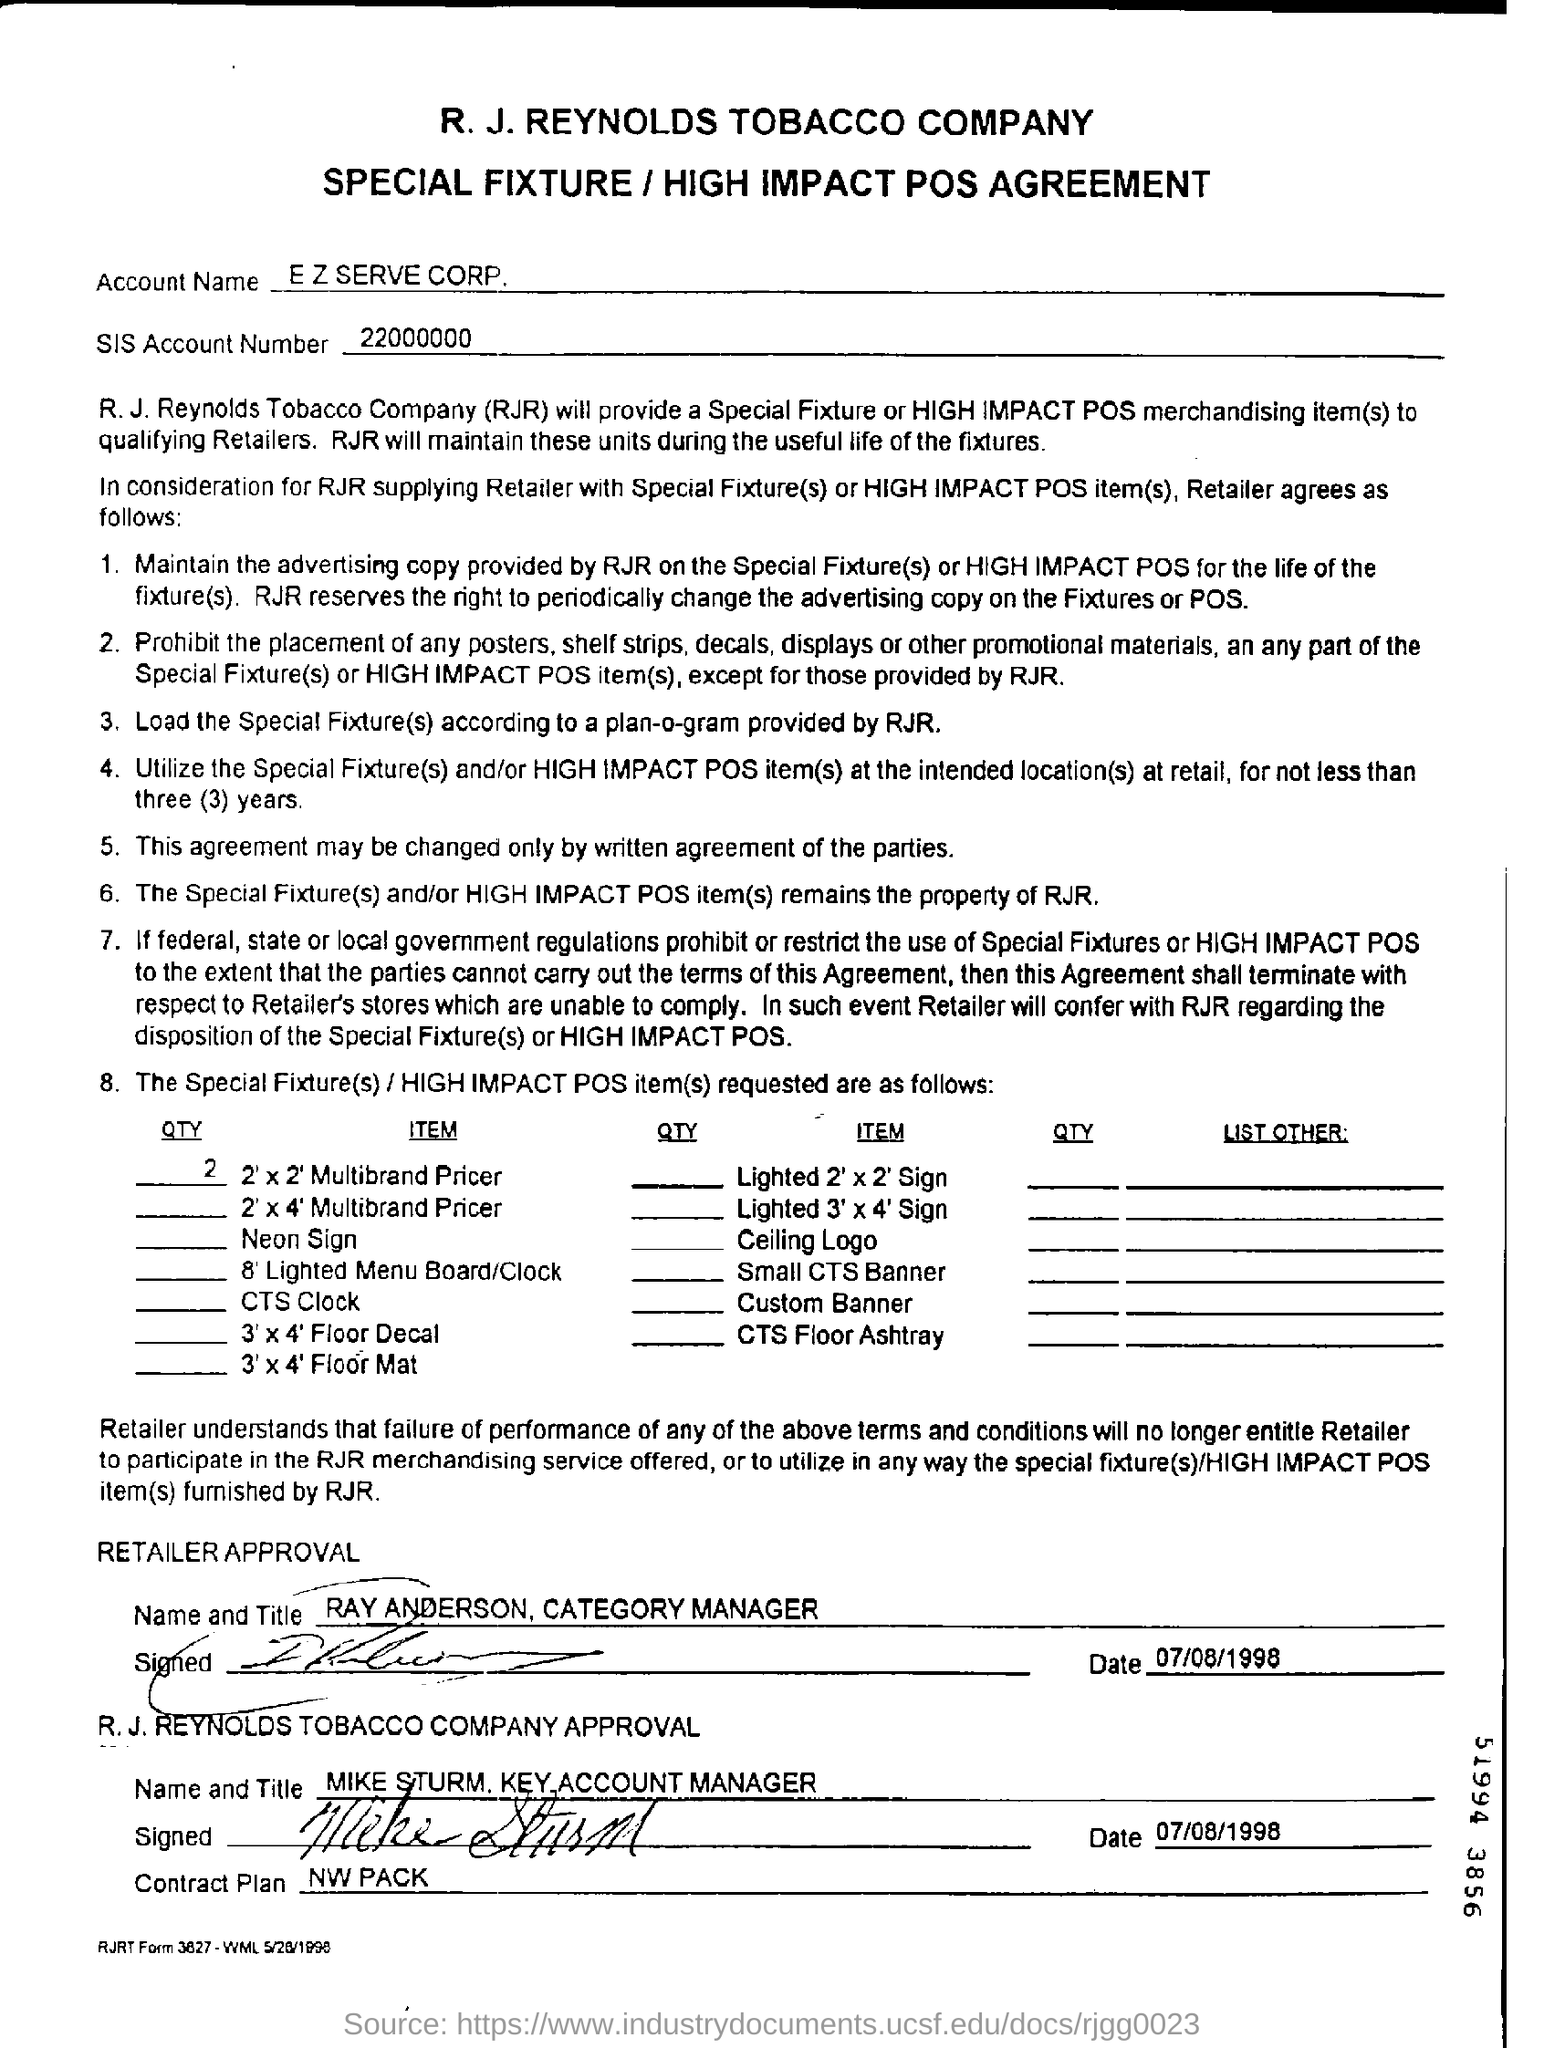Specify some key components in this picture. The date of retailer approval is July 8, 1998. The account number for the SIS is 22000000...". The account name is "E Z serve corp.". 